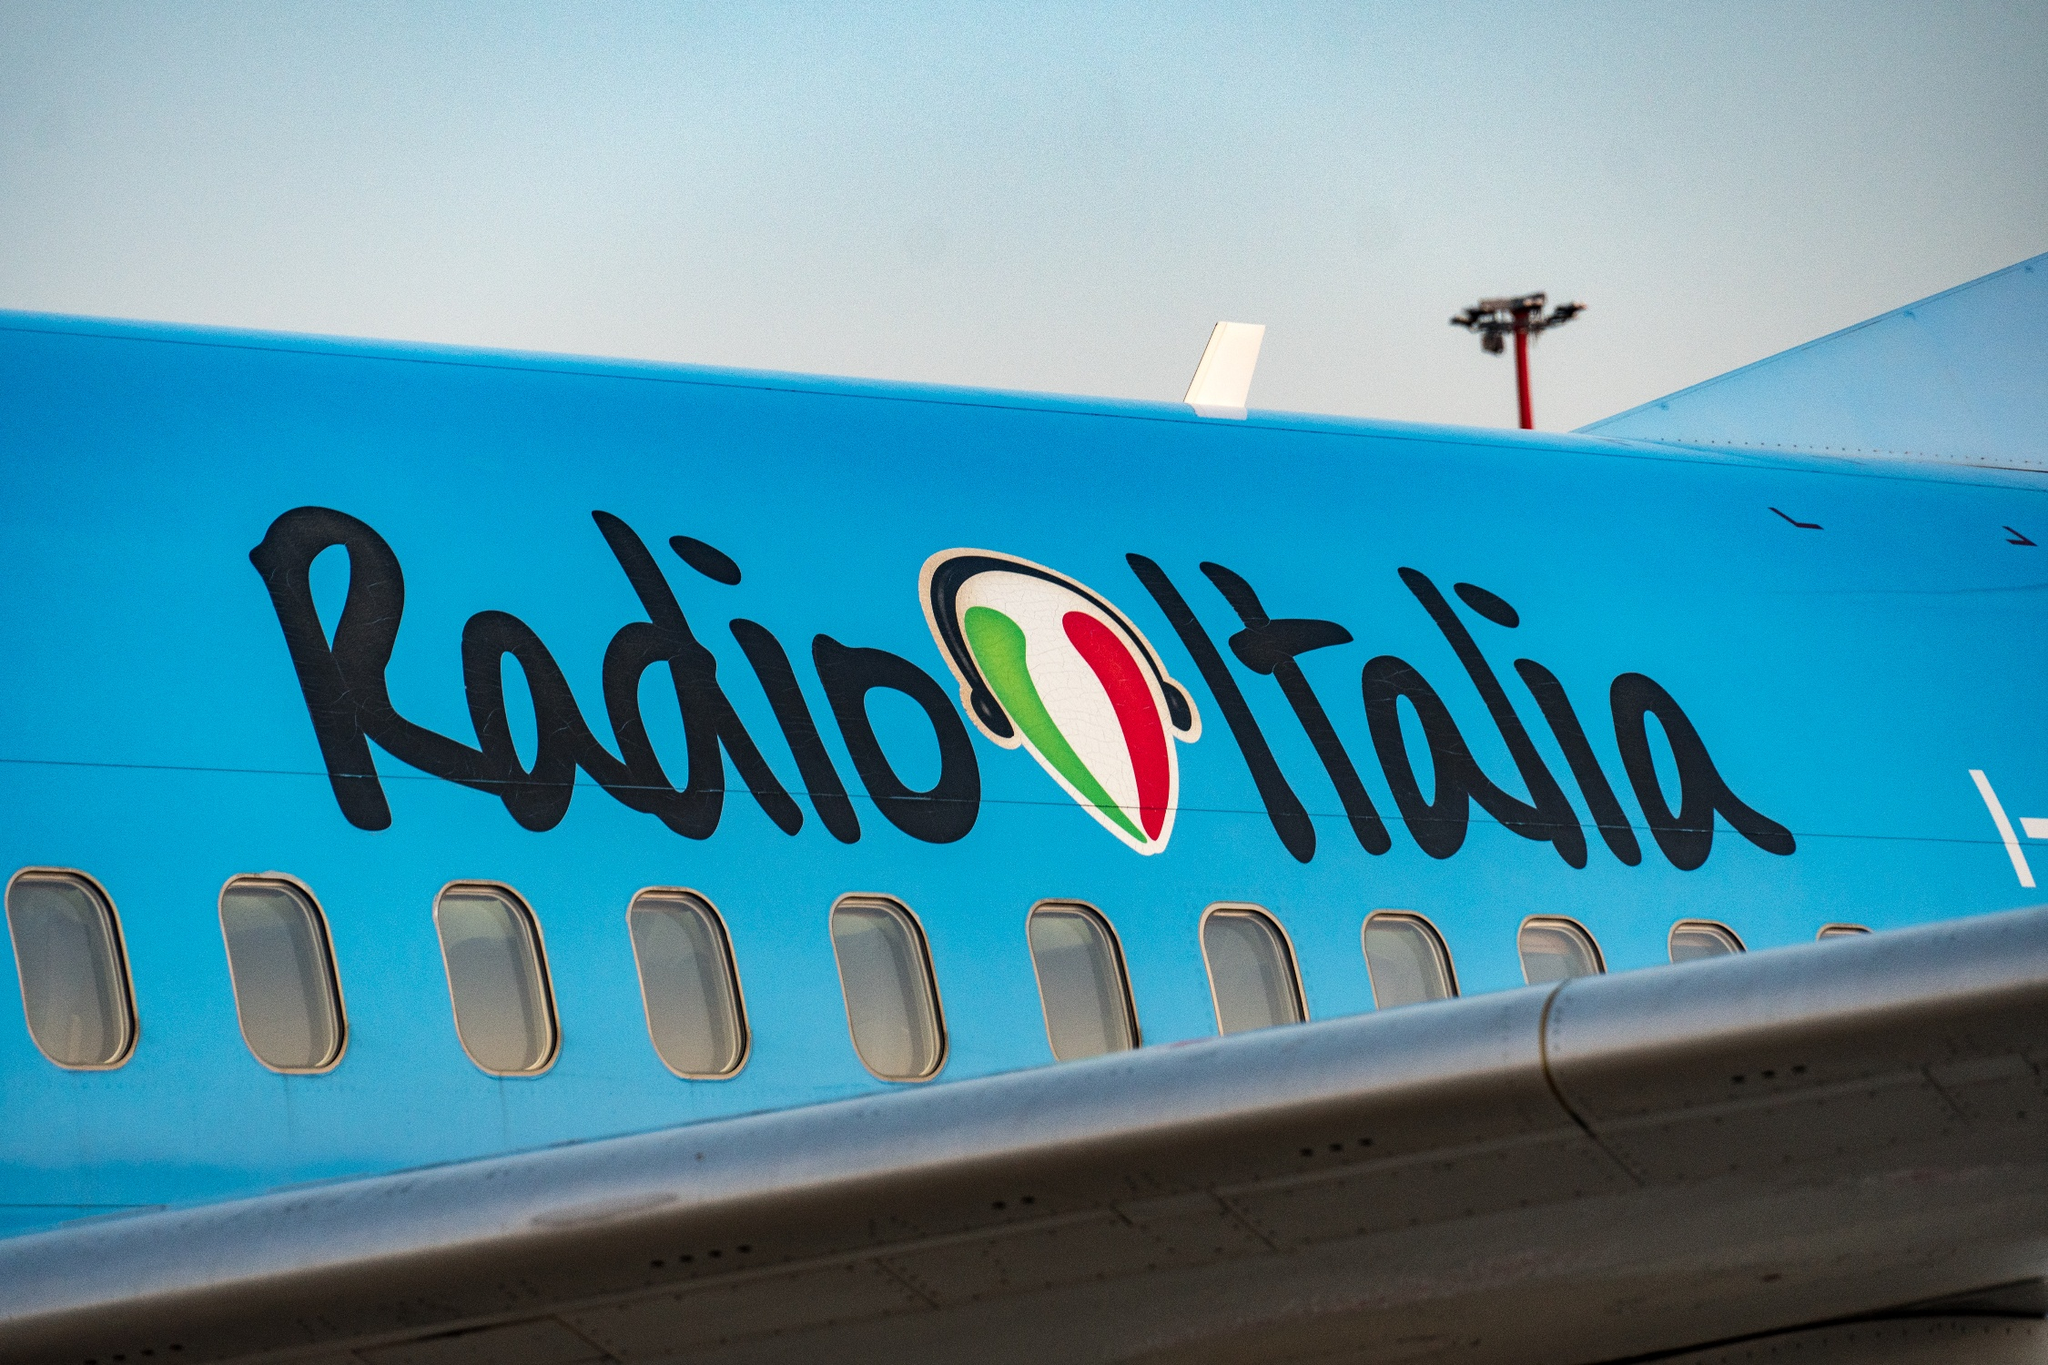How does the presence of the light pole influence the scene captured in this image? The presence of the light pole subtly blends urban infrastructure with the advanced technology of the airplane, providing a juxtaposition that highlights how technology intersects with everyday city life. It also adds a layer of realism to the scene, anchoring the soaring aircraft to the more mundane elements of ground-level urban settings. 